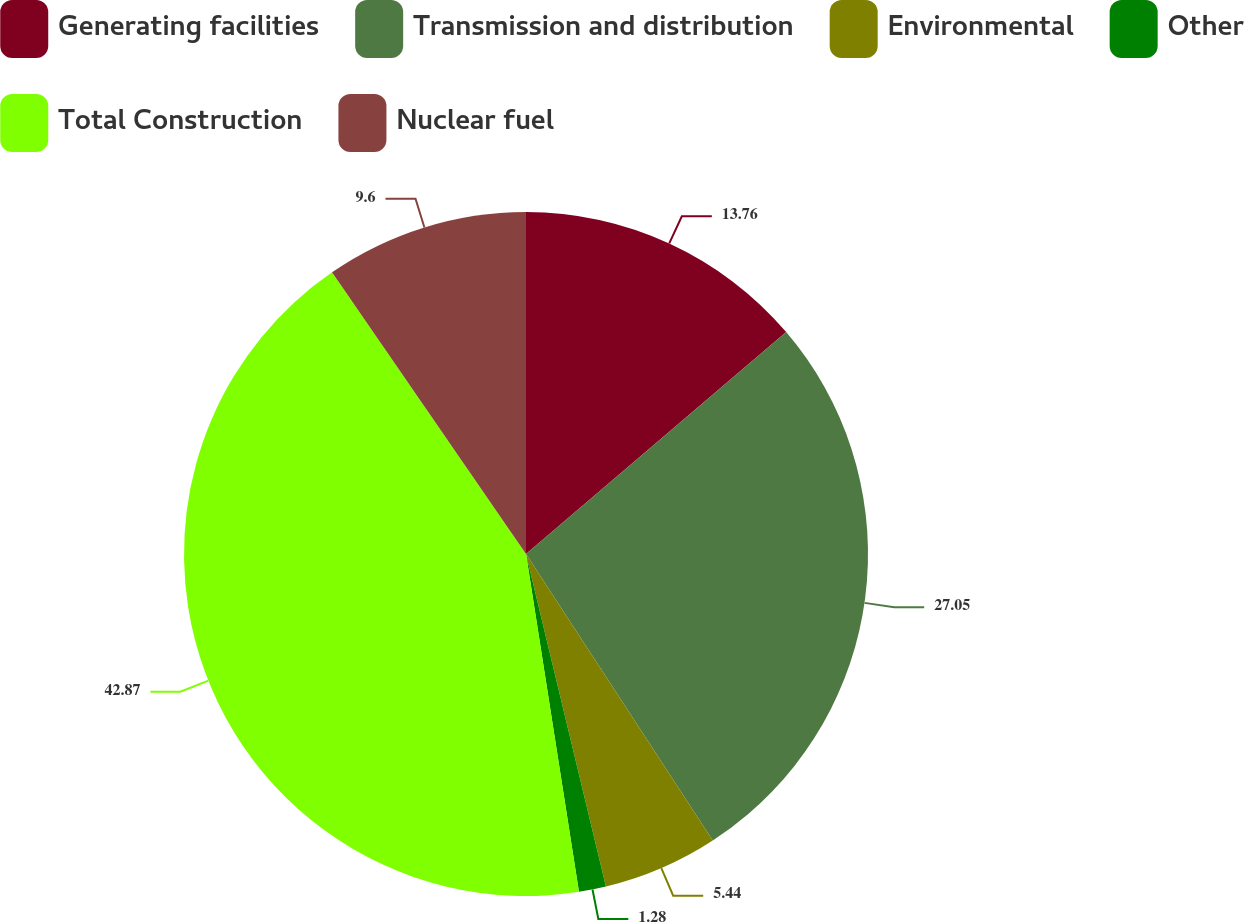Convert chart to OTSL. <chart><loc_0><loc_0><loc_500><loc_500><pie_chart><fcel>Generating facilities<fcel>Transmission and distribution<fcel>Environmental<fcel>Other<fcel>Total Construction<fcel>Nuclear fuel<nl><fcel>13.76%<fcel>27.05%<fcel>5.44%<fcel>1.28%<fcel>42.88%<fcel>9.6%<nl></chart> 